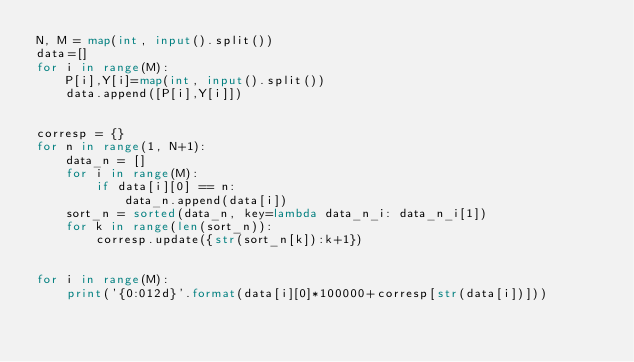Convert code to text. <code><loc_0><loc_0><loc_500><loc_500><_Python_>N, M = map(int, input().split())
data=[]
for i in range(M):
    P[i],Y[i]=map(int, input().split())
    data.append([P[i],Y[i]])

  
corresp = {}
for n in range(1, N+1):
    data_n = []
    for i in range(M):
        if data[i][0] == n:
            data_n.append(data[i])
    sort_n = sorted(data_n, key=lambda data_n_i: data_n_i[1])
    for k in range(len(sort_n)):
        corresp.update({str(sort_n[k]):k+1})
    

for i in range(M):
    print('{0:012d}'.format(data[i][0]*100000+corresp[str(data[i])]))
</code> 